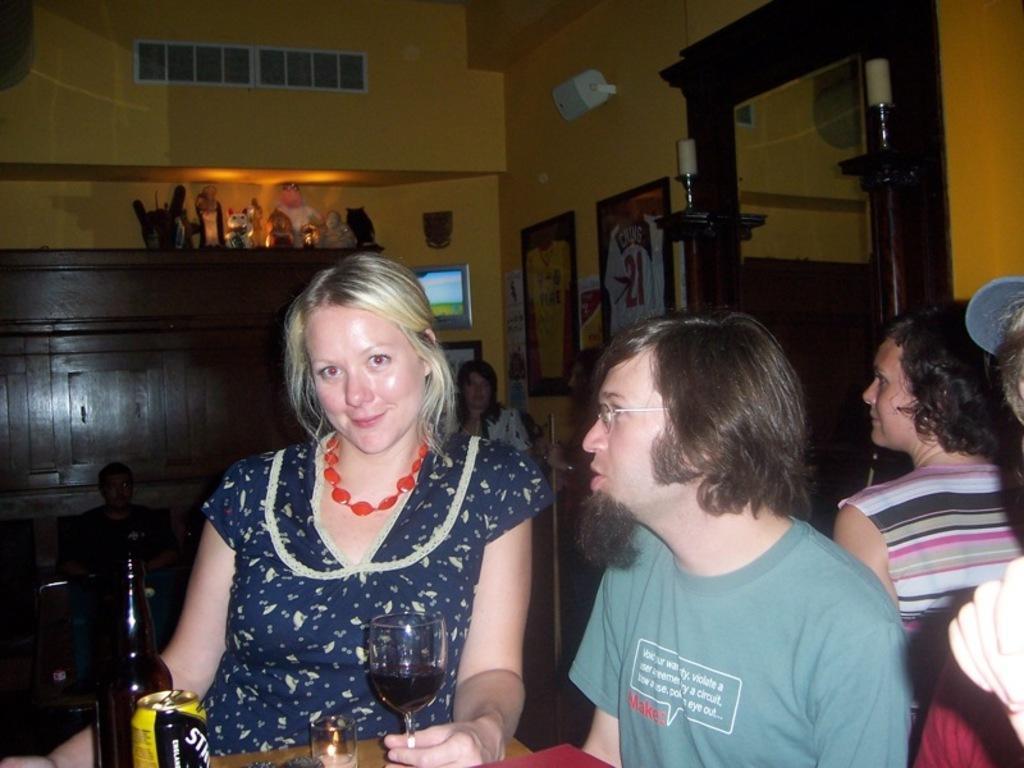Describe this image in one or two sentences. These persons are sitting on a chair. In-front of this person there is a table, on a table there is a tin, bottle and glass. Far this persons are sitting. Above this cupboard there are toys and sculpture. A different type of pictures on wall. These are candles. 